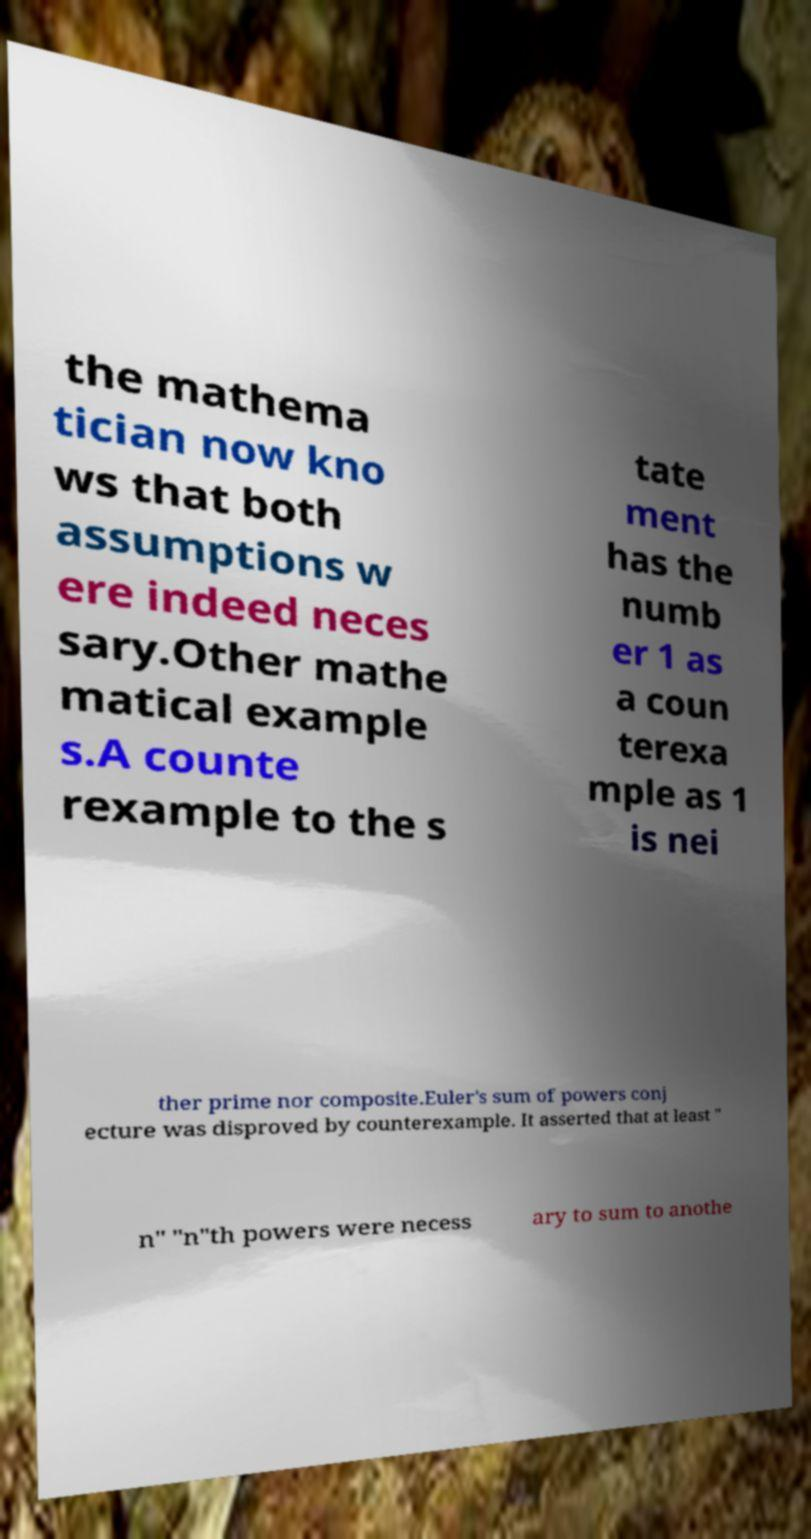For documentation purposes, I need the text within this image transcribed. Could you provide that? the mathema tician now kno ws that both assumptions w ere indeed neces sary.Other mathe matical example s.A counte rexample to the s tate ment has the numb er 1 as a coun terexa mple as 1 is nei ther prime nor composite.Euler's sum of powers conj ecture was disproved by counterexample. It asserted that at least " n" "n"th powers were necess ary to sum to anothe 